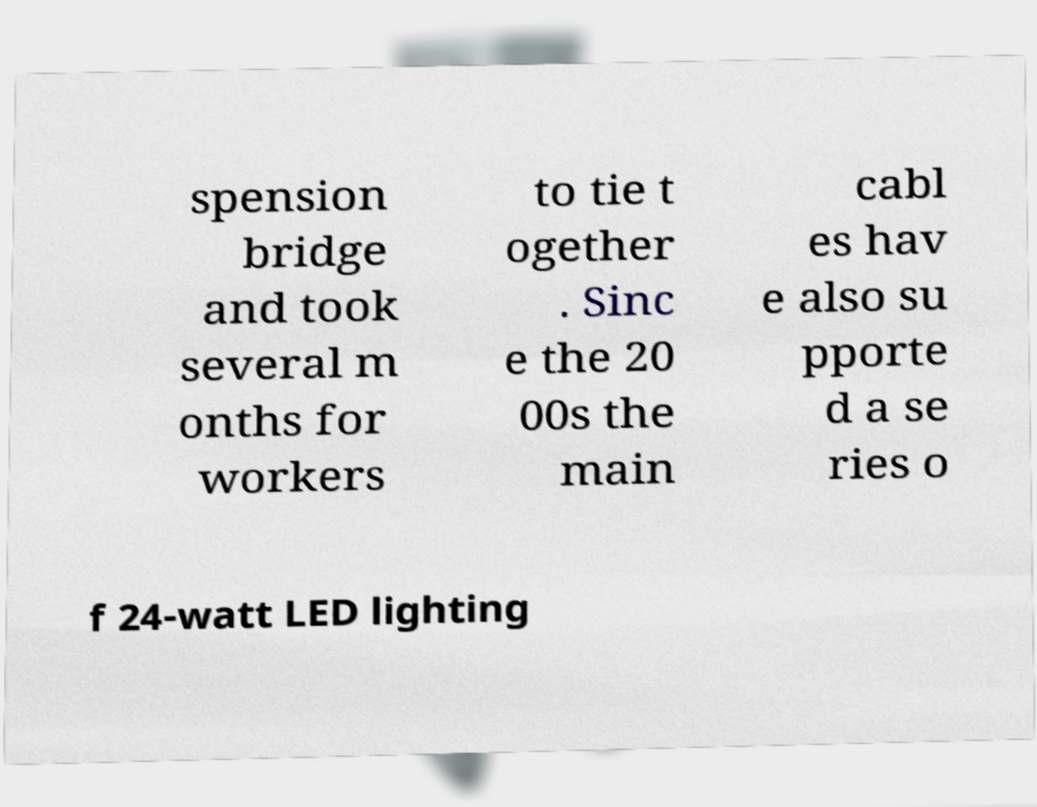Can you accurately transcribe the text from the provided image for me? spension bridge and took several m onths for workers to tie t ogether . Sinc e the 20 00s the main cabl es hav e also su pporte d a se ries o f 24-watt LED lighting 